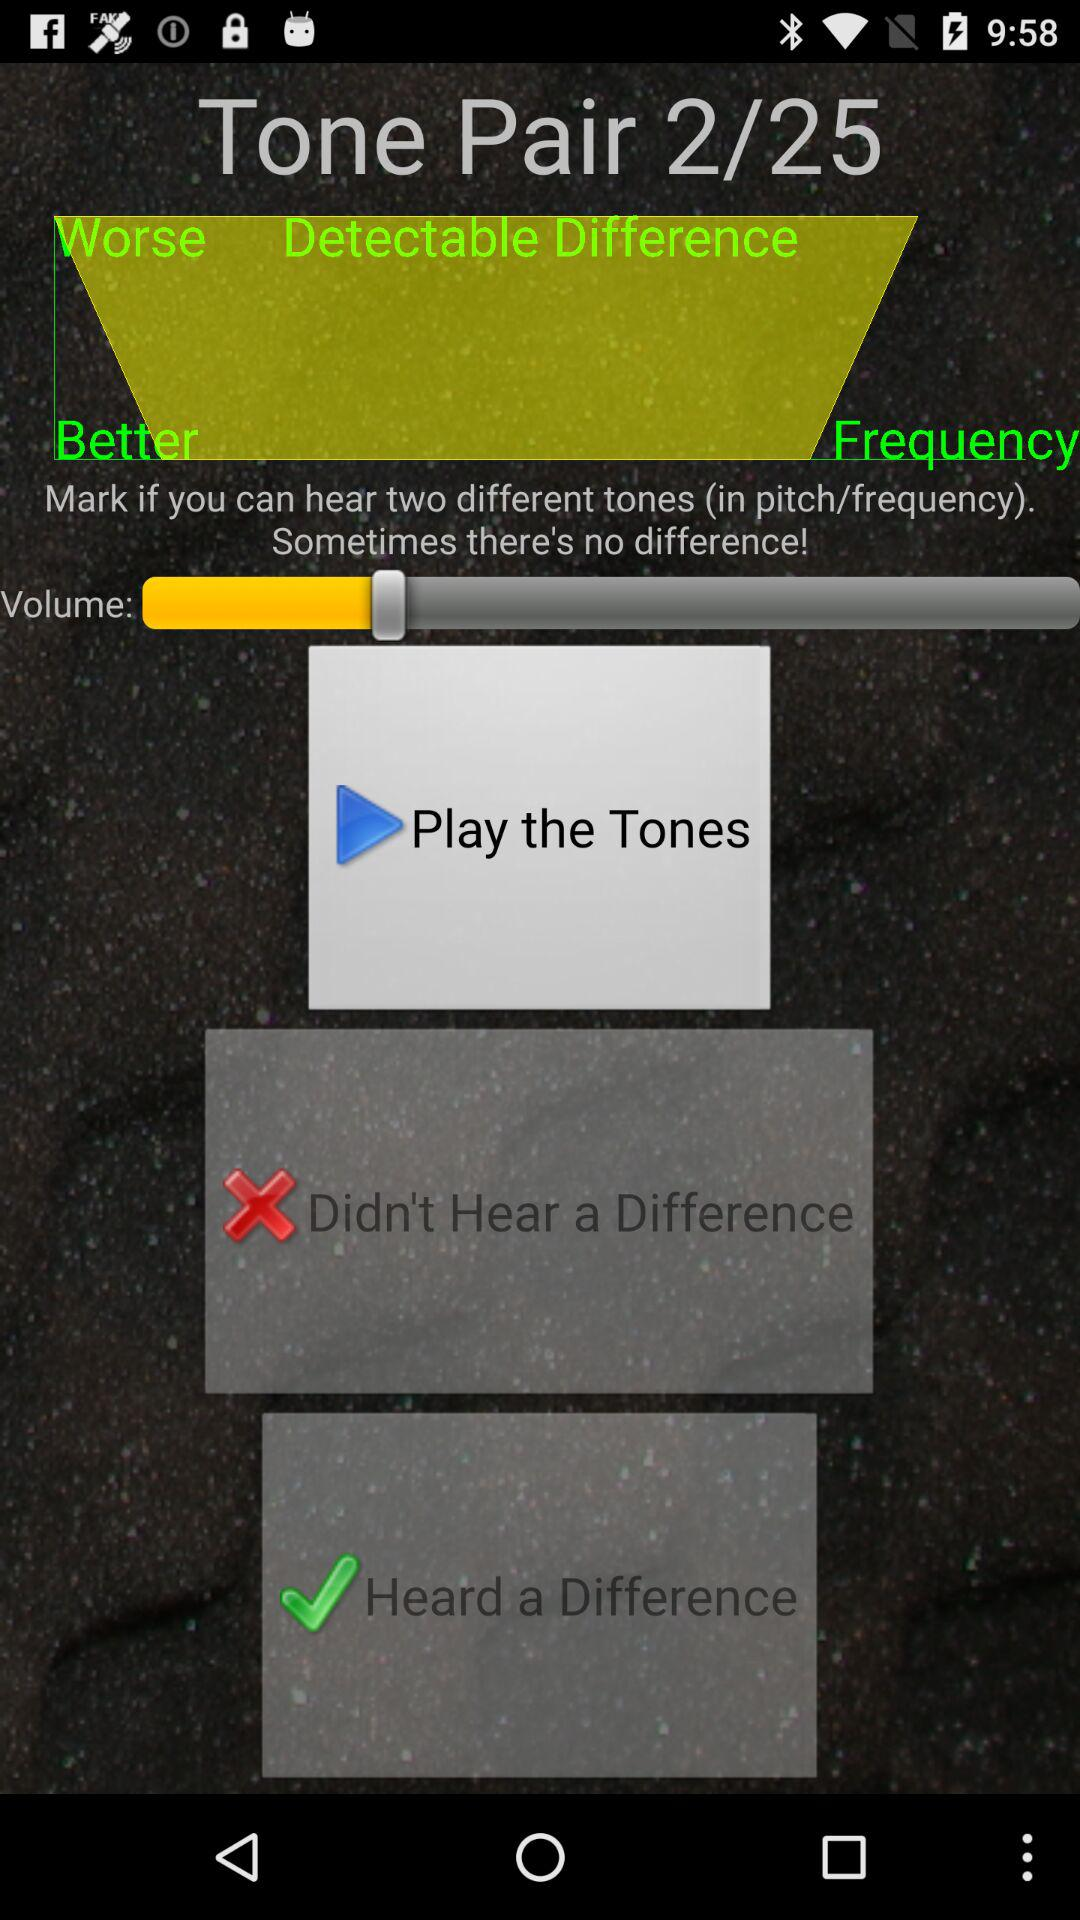How many tones are there in this tone pair?
Answer the question using a single word or phrase. 2 